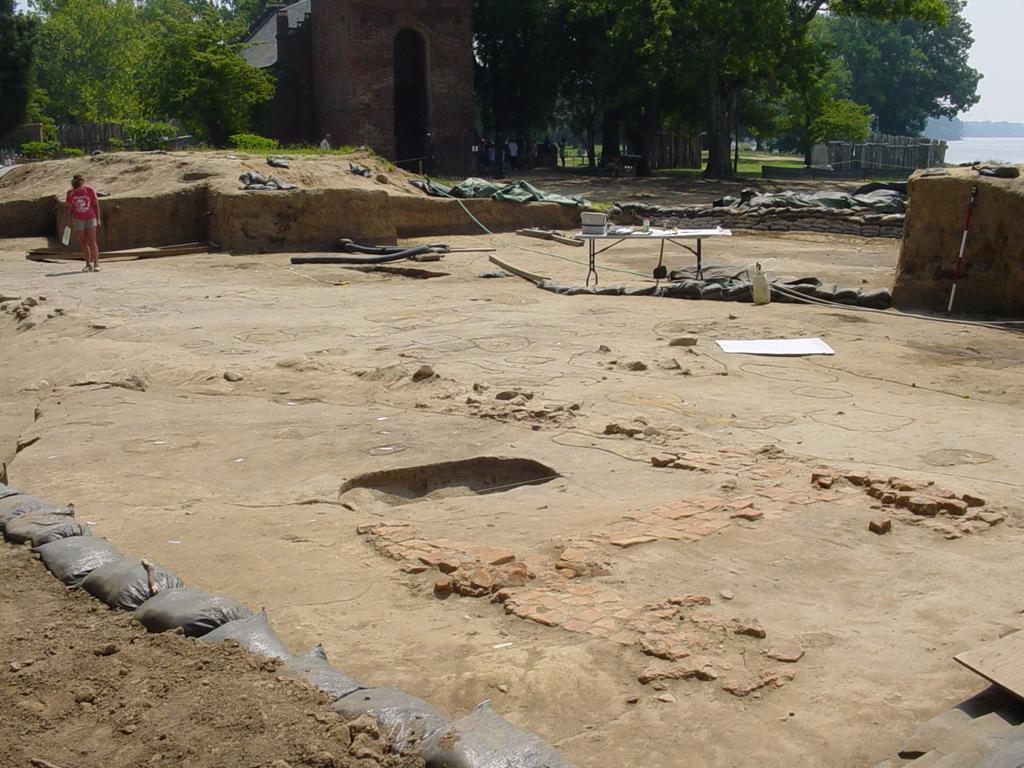Can you describe this image briefly? There are gray color packets arranged near mud road. In the background, there is a person in red color t-shirt holding a bottle and standing on the ground, there are packets arranged on the ground, there is a building having roof, there are trees, there is water and there is sky. 